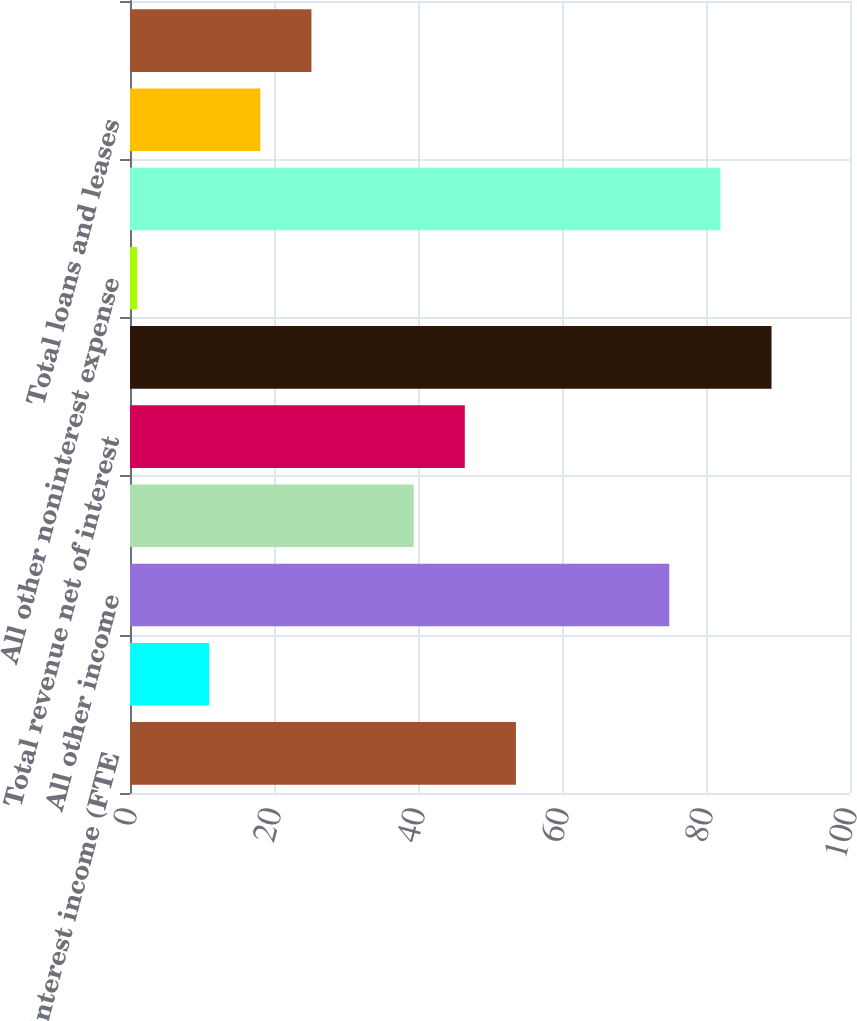Convert chart to OTSL. <chart><loc_0><loc_0><loc_500><loc_500><bar_chart><fcel>Net interest income (FTE<fcel>Card income<fcel>All other income<fcel>Total noninterest income<fcel>Total revenue net of interest<fcel>Provision for credit losses<fcel>All other noninterest expense<fcel>Income tax expense (FTE basis)<fcel>Total loans and leases<fcel>Total earning assets<nl><fcel>53.6<fcel>11<fcel>74.9<fcel>39.4<fcel>46.5<fcel>89.1<fcel>1<fcel>82<fcel>18.1<fcel>25.2<nl></chart> 